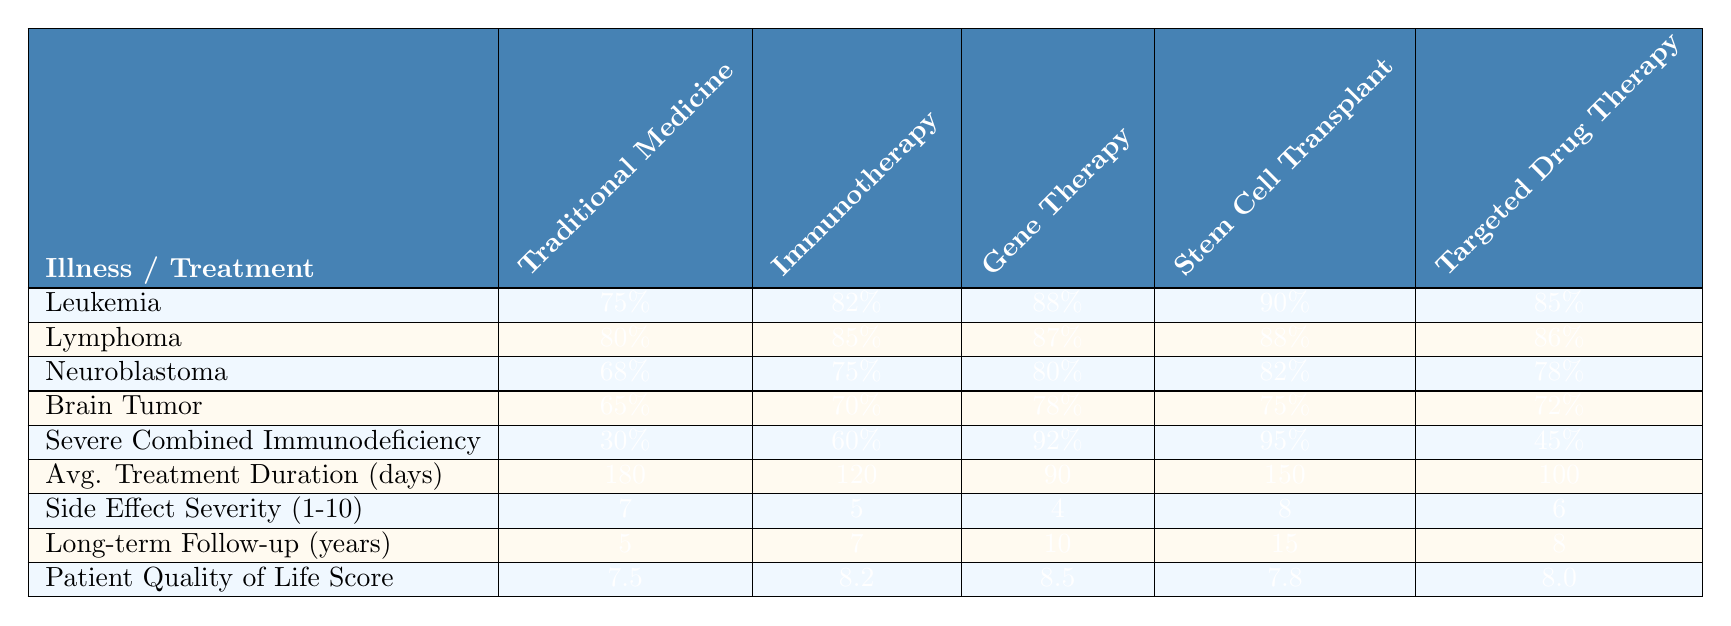What is the recovery rate for Neuroblastoma using Gene Therapy? The table shows that the recovery rate for Neuroblastoma when treated with Gene Therapy is listed as 80%.
Answer: 80% Which treatment has the highest recovery rate for Brain Tumor? According to the table, the treatment with the highest recovery rate for Brain Tumor is Gene Therapy, with a rate of 78%.
Answer: Gene Therapy What is the average treatment duration for Immunotherapy? The average treatment duration for Immunotherapy is found in the table as 120 days.
Answer: 120 days Is the recovery rate for Severe Combined Immunodeficiency higher with Stem Cell Transplant or Gene Therapy? The table indicates that the recovery rate for Severe Combined Immunodeficiency with Stem Cell Transplant is 95%, and with Gene Therapy it is 92%. Since 95% is greater than 92%, Stem Cell Transplant has the higher recovery rate.
Answer: Stem Cell Transplant What is the average recovery rate for Lymphoma across all treatments? The recovery rates for Lymphoma are: Traditional Medicine (80%), Immunotherapy (85%), Gene Therapy (87%), Stem Cell Transplant (88%), and Targeted Drug Therapy (86%). The average is calculated as (80 + 85 + 87 + 88 + 86) / 5 = 83.2%.
Answer: 83.2% Which treatment has the lowest side effect severity score? The table shows that Gene Therapy has the lowest side effect severity score of 4, as it is lower than the other treatments which range from 5 to 8.
Answer: Gene Therapy What is the total patient quality of life score for all treatments combined? The patient quality of life scores for each treatment are: Traditional Medicine (7.5), Immunotherapy (8.2), Gene Therapy (8.5), Stem Cell Transplant (7.8), and Targeted Drug Therapy (8.0). The total is calculated as 7.5 + 8.2 + 8.5 + 7.8 + 8.0 = 39.0.
Answer: 39.0 Which treatment requires the longest long-term follow-up period? The longest long-term follow-up period is for Stem Cell Transplant, which requires 15 years, as indicated in the table.
Answer: Stem Cell Transplant Is the recovery rate for Traditional Medicine higher than 70% for all illnesses listed? Checking the table shows that Traditional Medicine has recovery rates of 75% for Leukemia, 80% for Lymphoma, 68% for Neuroblastoma, 65% for Brain Tumor, and 30% for Severe Combined Immunodeficiency. Since it is not higher than 70% for Neuroblastoma and Severe Combined Immunodeficiency, the answer is no.
Answer: No What is the difference in recovery rate between Immunotherapy and Traditional Medicine for Leukemia? The recovery rates for Leukemia are 82% for Immunotherapy and 75% for Traditional Medicine. The difference is calculated as 82% - 75% = 7%.
Answer: 7% 